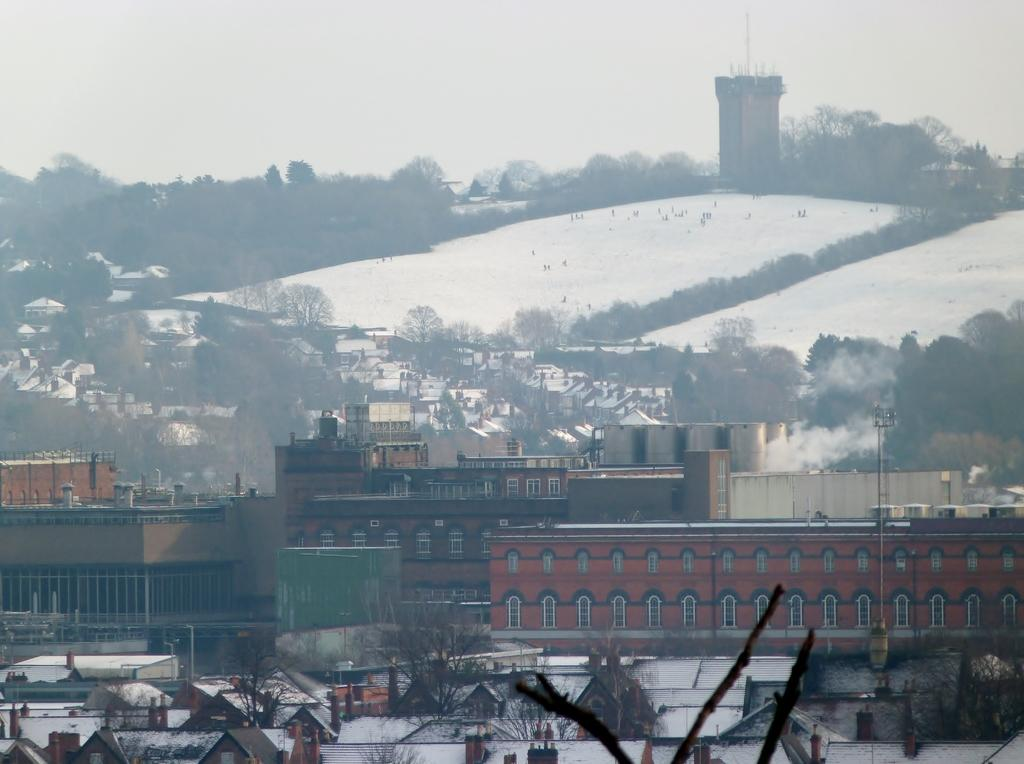What structures are located in the center of the image? There are buildings and sheds in the center of the image. What can be seen in the background of the image? There is snow, trees, poles, a tower, and the sky visible in the background of the image. How many chickens are sitting on the lip of the mitten in the image? There are no chickens or mittens present in the image. What type of lip can be seen on the tower in the image? There is no lip present on the tower in the image. 